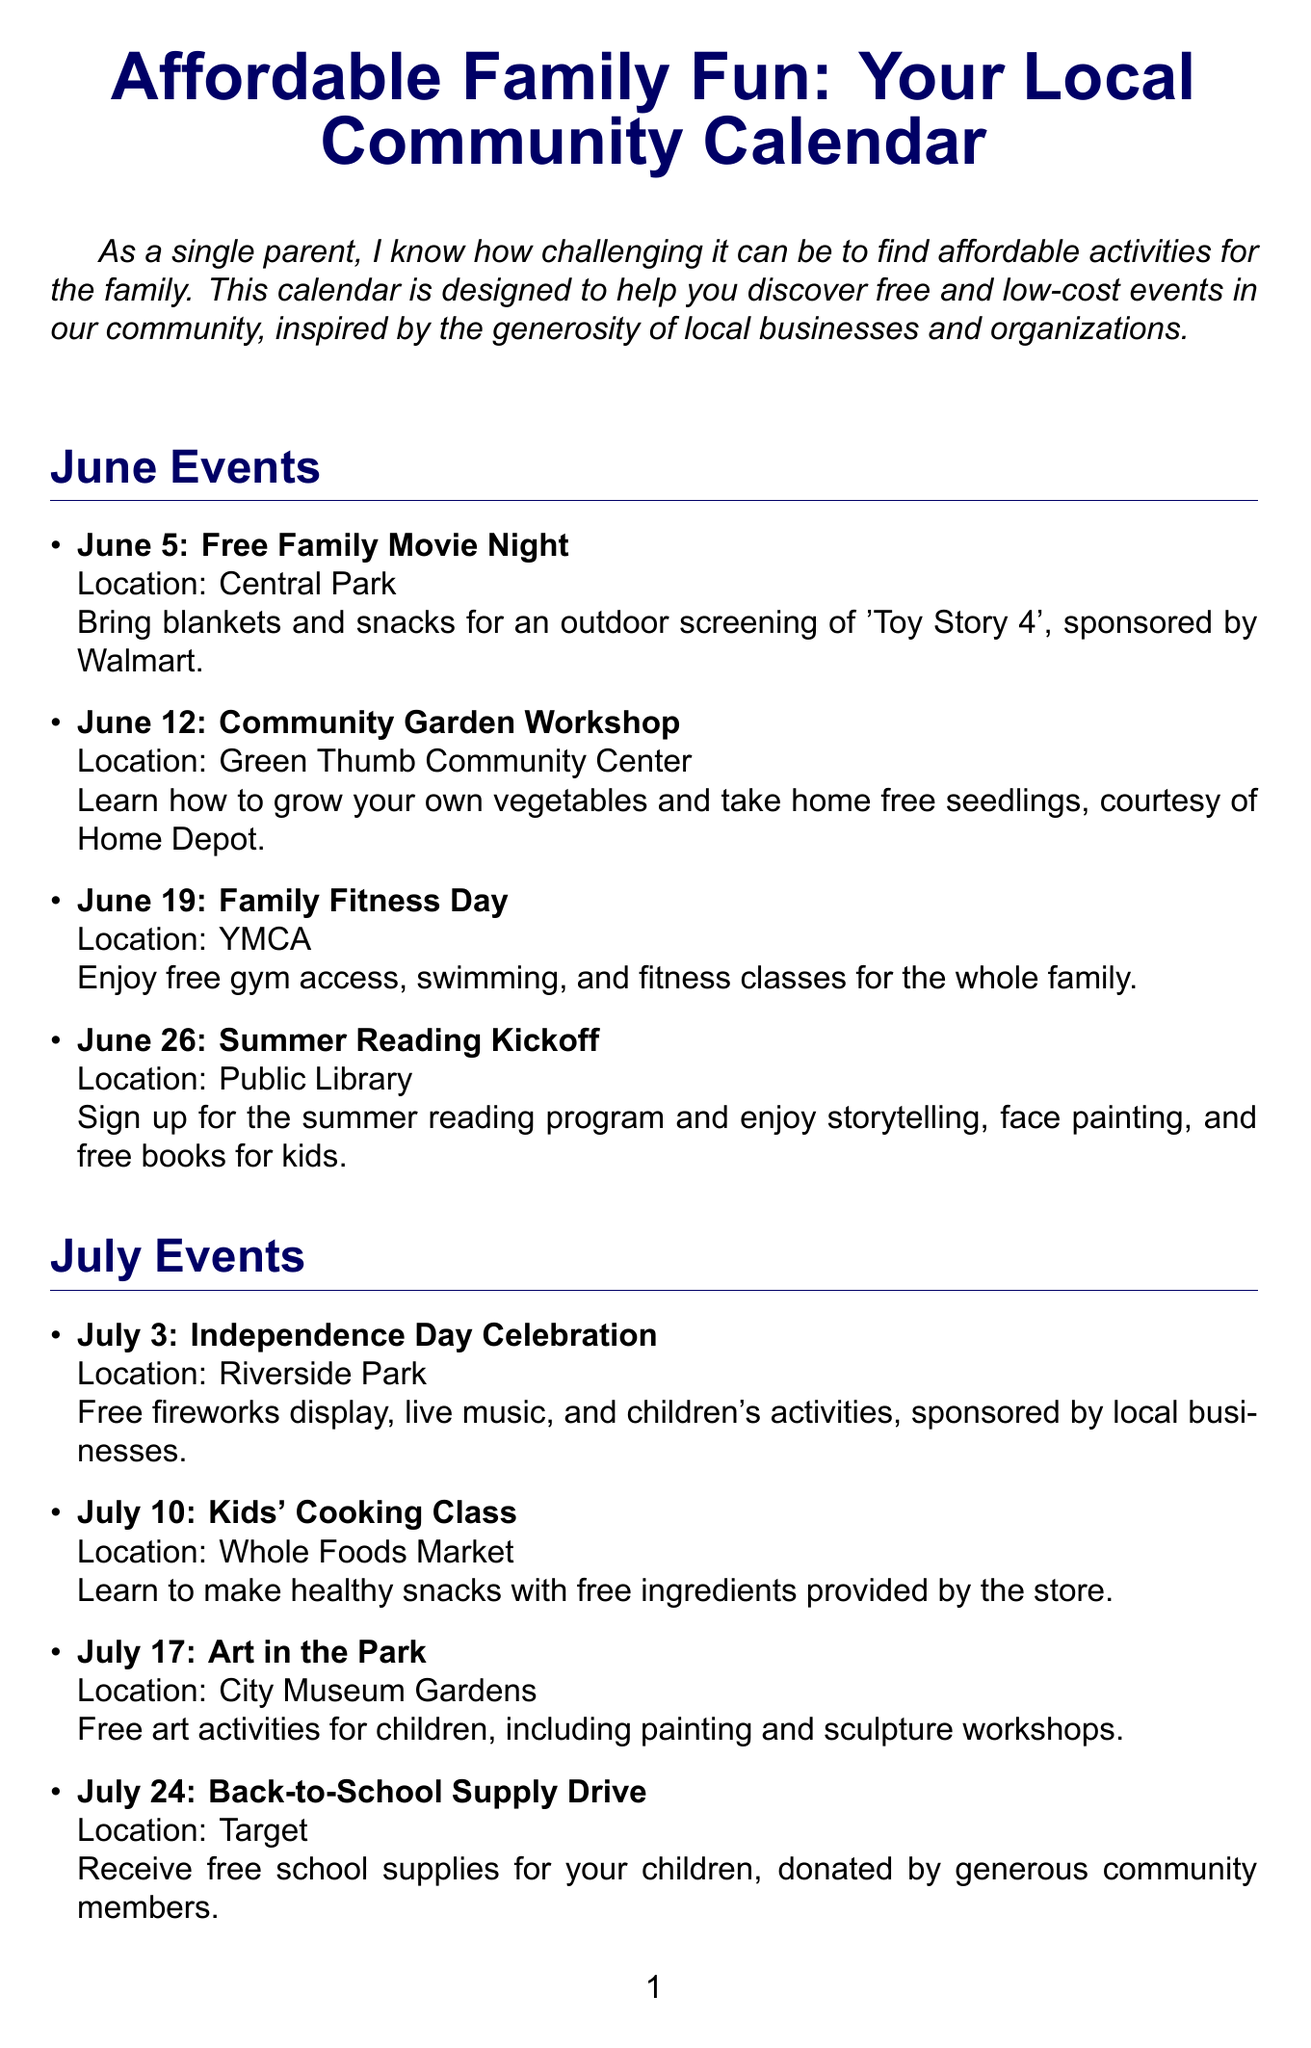What is the title of the newsletter? The title is prominently stated at the beginning of the document.
Answer: Affordable Family Fun: Your Local Community Calendar What is the date of the Free Family Movie Night? The date is listed under June events.
Answer: June 5 Where is the Family Fitness Day taking place? The location is specified in the event details for June 19.
Answer: YMCA What ongoing resource provides free groceries? The resource is mentioned in the ongoing resources section.
Answer: Food Bank Distribution How often does the Family Health Clinic occur? The schedule indicates the frequency of this resource.
Answer: First Saturday of each month What event is scheduled for July 10? The event is listed in the July events section.
Answer: Kids' Cooking Class Which organization is sponsoring the Summer Reading Kickoff? The sponsorship is mentioned in the event description.
Answer: Public Library What type of activities are offered during the Art in the Park event? The event description specifies the types of activities included.
Answer: Free art activities How many resources are listed in the ongoing resources section? The number of listed resources can be counted in the respective section.
Answer: Three 